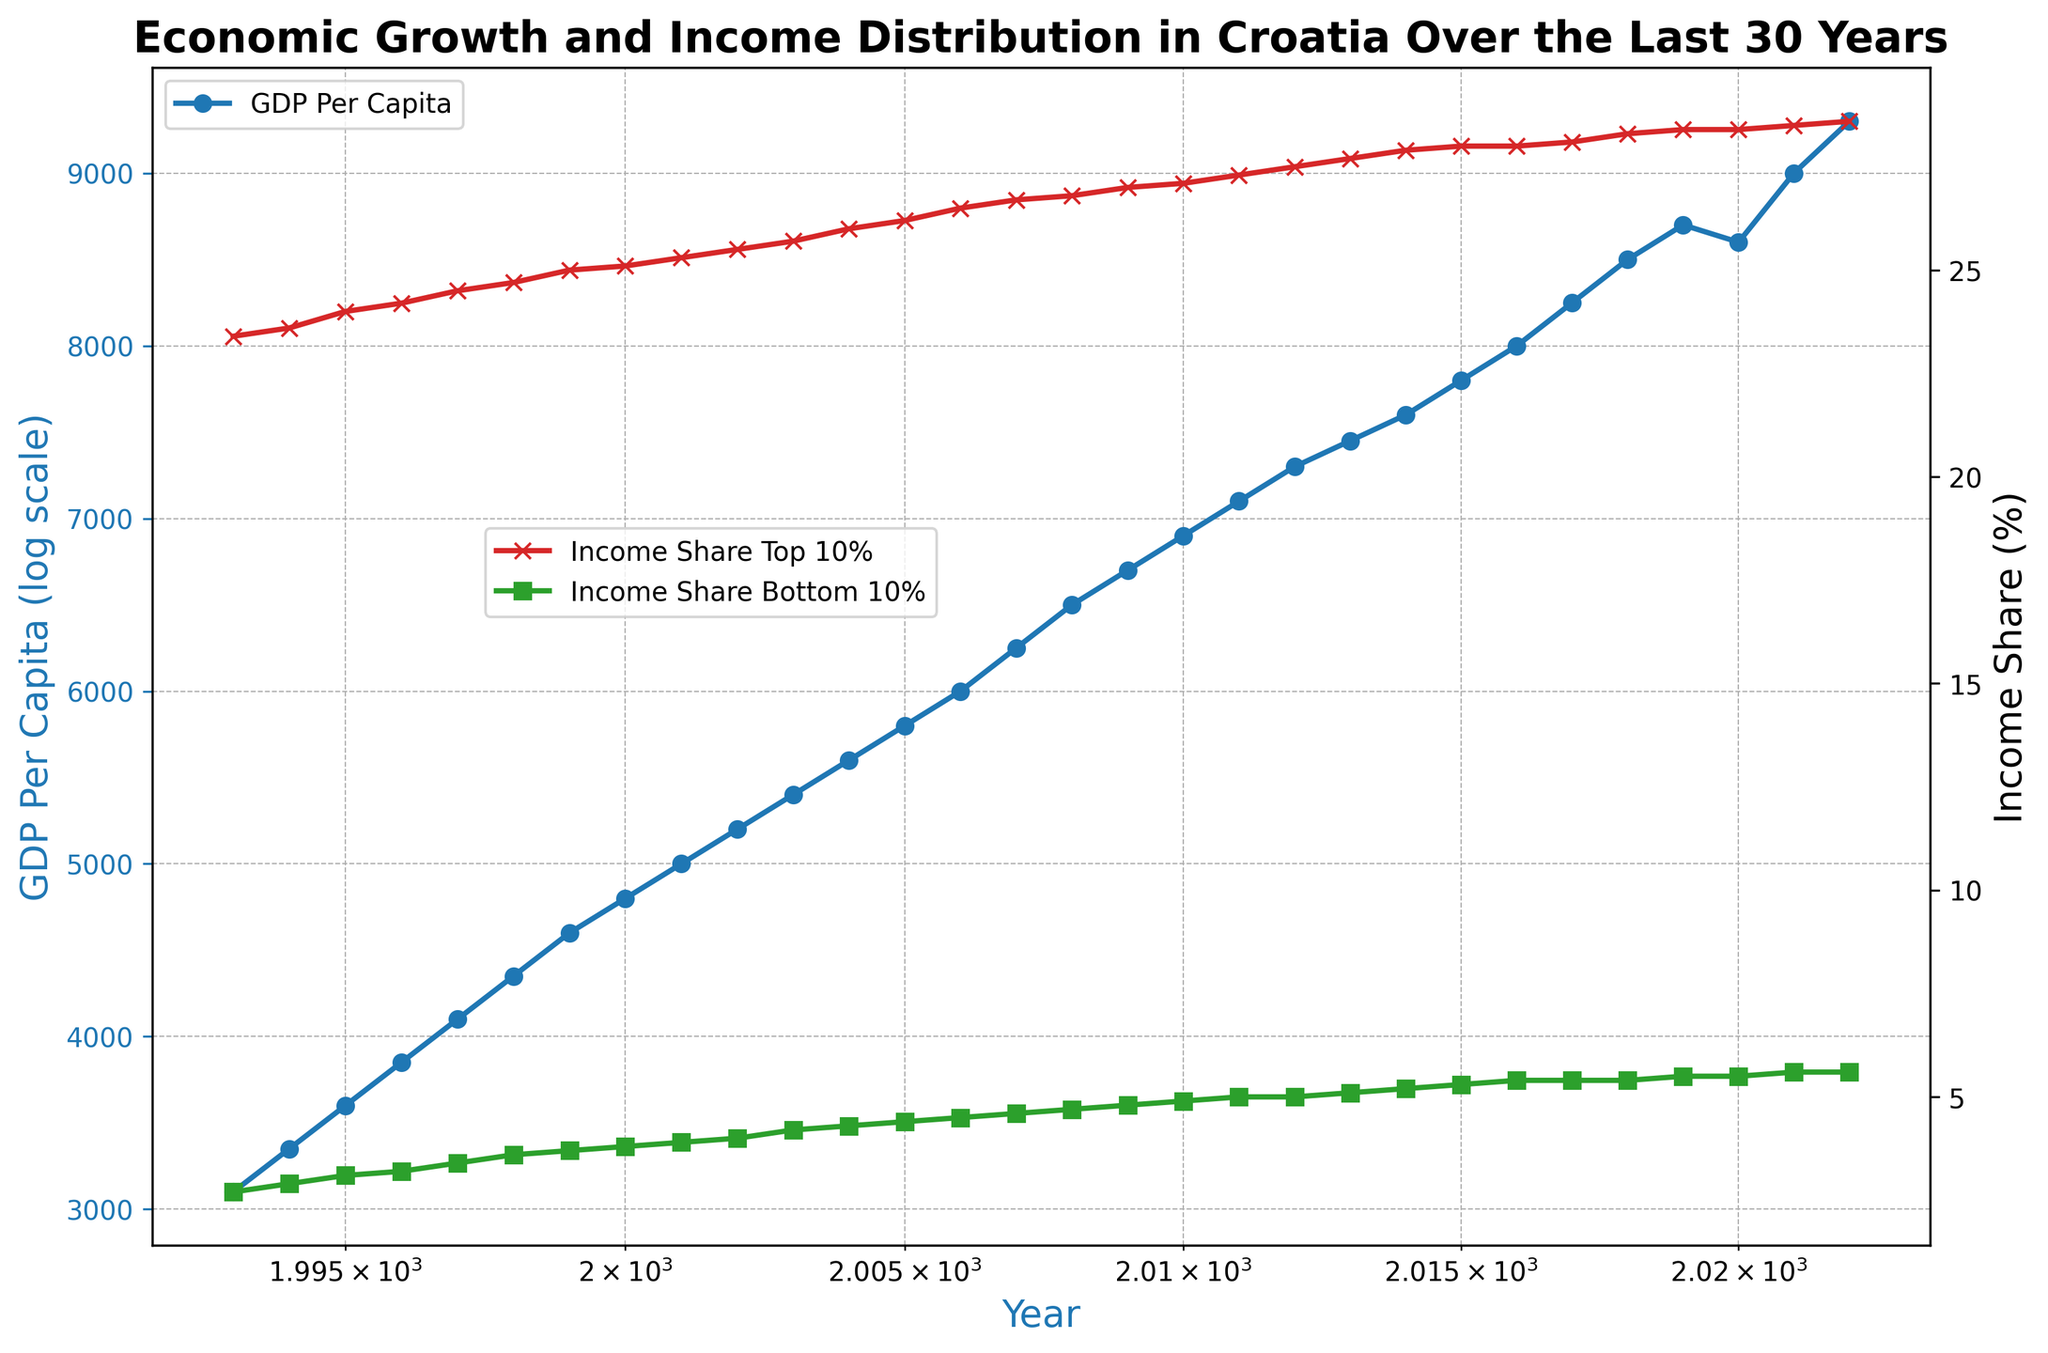What trend is observed in GDP per capita over the last 30 years? Observing the blue line on the log-scaled x-axis shows a consistent upward trend in GDP per capita from 1993 to 2022. This indicates overall economic growth.
Answer: Upward trend In what year did the income share of the top 10% surpass 28%? By analyzing the red line, we see that the income share of the top 10% first surpassed 28% in 2015.
Answer: 2015 Which year showed a decrease in GDP per capita while the income shares remained stable or increased? GDP per capita (blue line) decreased in 2020, but both income shares for the top 10% (red line) and bottom 10% (green line) remained stable.
Answer: 2020 How many years show a GDP per capita above $8000? From the blue line, years showing a GDP per capita above $8000 are 2016 to 2022, totaling 7 years.
Answer: 7 years What is the difference in income share between the top 10% and the bottom 10% in 2022? In 2022, the income share of the top 10% is 28.6%, and the bottom 10% is 5.6%. The difference is 28.6% - 5.6% = 23%.
Answer: 23% How significant is the increase in GDP per capita from 1993 to 2022? In 1993, the GDP per capita was $3100, whereas in 2022, it was $9300. The increase is $9300 - $3100 = $6200.
Answer: $6200 Does the income share of the bottom 10% ever exceed 5%? If so, when? The green line shows that the income share of the bottom 10% exceeds 5% starting in 2011 and stays above it through subsequent years.
Answer: Yes, from 2011 onward Compare the income share of the top 10% and the bottom 10% in the year 2000. In 2000, the red line (top 10%) is at 25.1%, and the green line (bottom 10%) is at 3.8%. The top 10% has a significantly higher share than the bottom 10%.
Answer: 25.1% (top 10%), 3.8% (bottom 10%) What can be concluded about income inequality trends from 1993 to 2022? The increasing gap between the red line (top 10%) and the green line (bottom 10%) indicates growing income inequality over the period.
Answer: Growing inequality What year sees the most significant jump in GDP per capita? The blue line shows a notable jump in GDP per capita from 2020 ($8600) to 2021 ($9000), an increase of $400.
Answer: 2021 